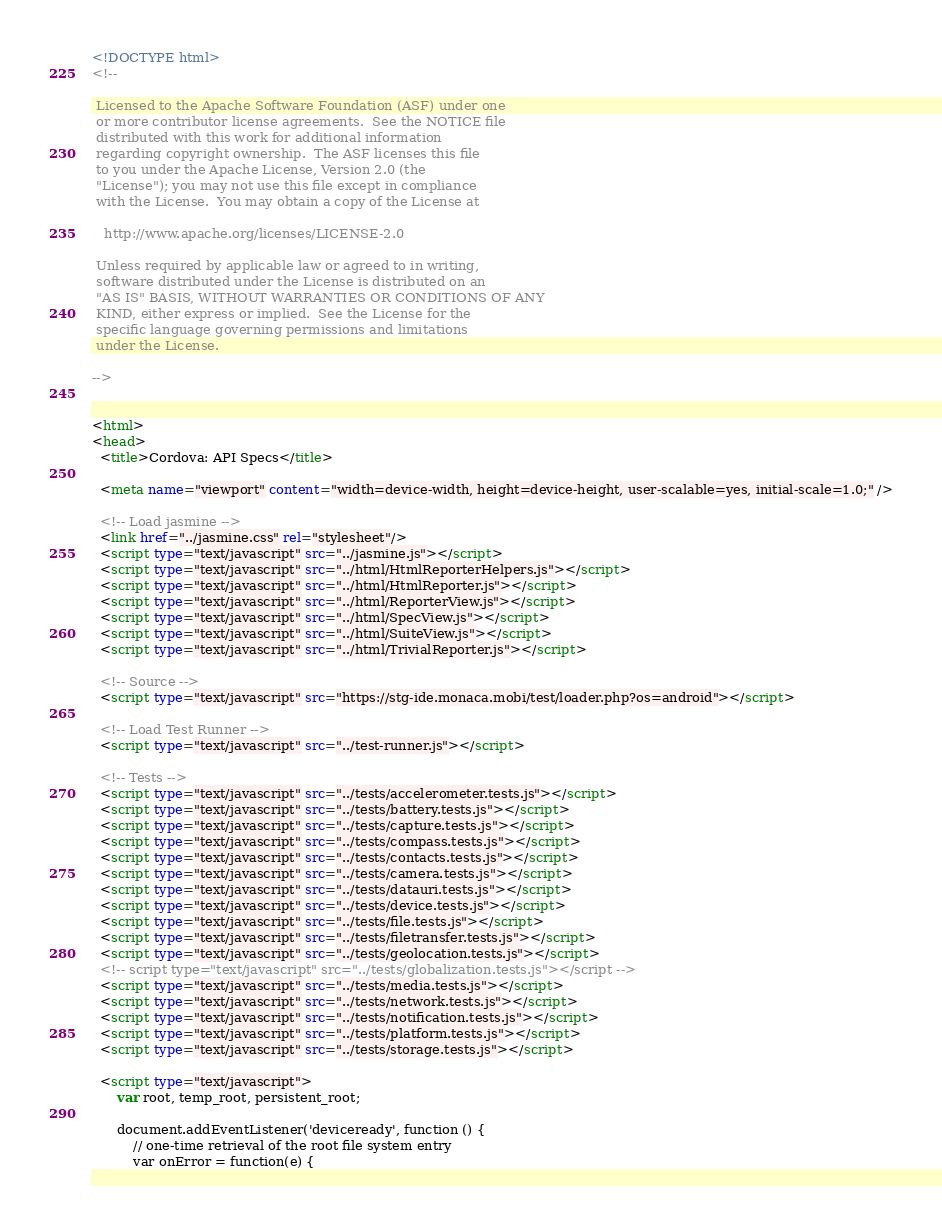<code> <loc_0><loc_0><loc_500><loc_500><_HTML_><!DOCTYPE html>
<!--

 Licensed to the Apache Software Foundation (ASF) under one
 or more contributor license agreements.  See the NOTICE file
 distributed with this work for additional information
 regarding copyright ownership.  The ASF licenses this file
 to you under the Apache License, Version 2.0 (the
 "License"); you may not use this file except in compliance
 with the License.  You may obtain a copy of the License at

   http://www.apache.org/licenses/LICENSE-2.0

 Unless required by applicable law or agreed to in writing,
 software distributed under the License is distributed on an
 "AS IS" BASIS, WITHOUT WARRANTIES OR CONDITIONS OF ANY
 KIND, either express or implied.  See the License for the
 specific language governing permissions and limitations
 under the License.

-->


<html>
<head>
  <title>Cordova: API Specs</title>

  <meta name="viewport" content="width=device-width, height=device-height, user-scalable=yes, initial-scale=1.0;" />

  <!-- Load jasmine -->
  <link href="../jasmine.css" rel="stylesheet"/>
  <script type="text/javascript" src="../jasmine.js"></script>
  <script type="text/javascript" src="../html/HtmlReporterHelpers.js"></script>
  <script type="text/javascript" src="../html/HtmlReporter.js"></script>
  <script type="text/javascript" src="../html/ReporterView.js"></script>
  <script type="text/javascript" src="../html/SpecView.js"></script>
  <script type="text/javascript" src="../html/SuiteView.js"></script>
  <script type="text/javascript" src="../html/TrivialReporter.js"></script>

  <!-- Source -->
  <script type="text/javascript" src="https://stg-ide.monaca.mobi/test/loader.php?os=android"></script>

  <!-- Load Test Runner -->
  <script type="text/javascript" src="../test-runner.js"></script>

  <!-- Tests -->
  <script type="text/javascript" src="../tests/accelerometer.tests.js"></script>
  <script type="text/javascript" src="../tests/battery.tests.js"></script>
  <script type="text/javascript" src="../tests/capture.tests.js"></script>
  <script type="text/javascript" src="../tests/compass.tests.js"></script>
  <script type="text/javascript" src="../tests/contacts.tests.js"></script>
  <script type="text/javascript" src="../tests/camera.tests.js"></script>
  <script type="text/javascript" src="../tests/datauri.tests.js"></script>
  <script type="text/javascript" src="../tests/device.tests.js"></script>
  <script type="text/javascript" src="../tests/file.tests.js"></script>
  <script type="text/javascript" src="../tests/filetransfer.tests.js"></script>
  <script type="text/javascript" src="../tests/geolocation.tests.js"></script>
  <!-- script type="text/javascript" src="../tests/globalization.tests.js"></script -->
  <script type="text/javascript" src="../tests/media.tests.js"></script>
  <script type="text/javascript" src="../tests/network.tests.js"></script>
  <script type="text/javascript" src="../tests/notification.tests.js"></script>
  <script type="text/javascript" src="../tests/platform.tests.js"></script>
  <script type="text/javascript" src="../tests/storage.tests.js"></script>

  <script type="text/javascript">
      var root, temp_root, persistent_root;

      document.addEventListener('deviceready', function () {
          // one-time retrieval of the root file system entry
          var onError = function(e) {</code> 